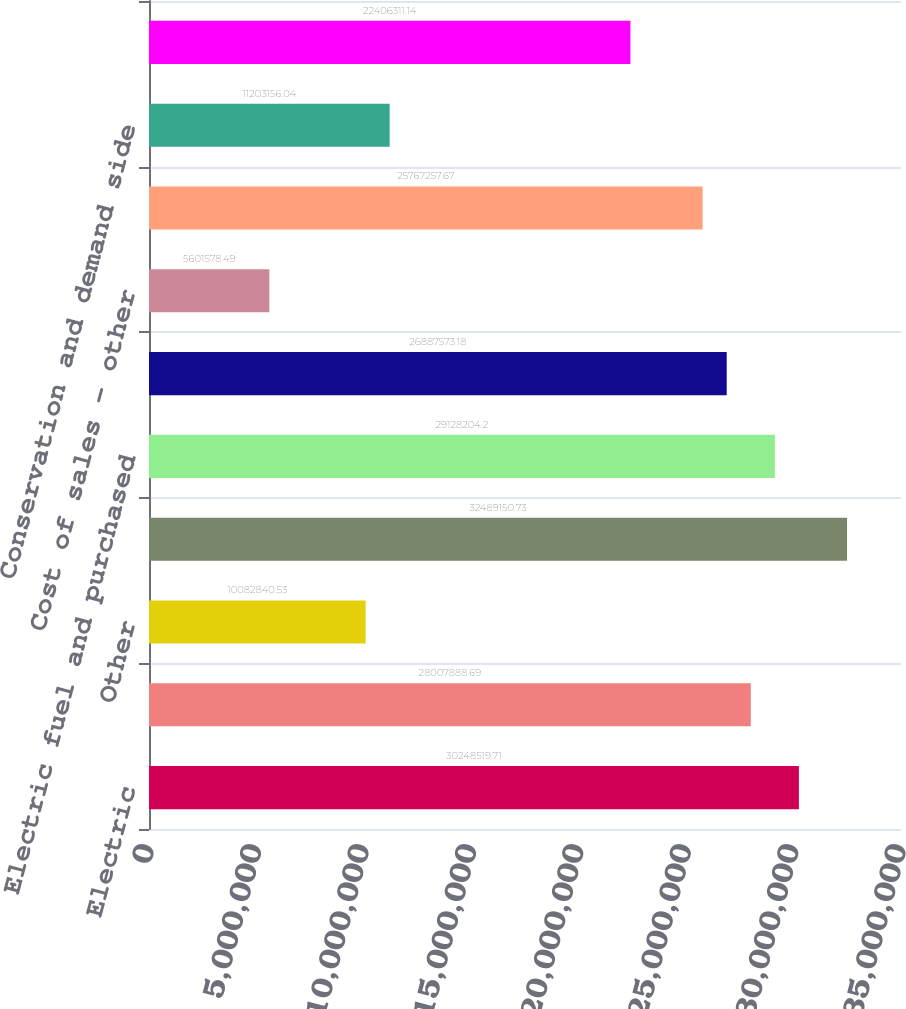Convert chart to OTSL. <chart><loc_0><loc_0><loc_500><loc_500><bar_chart><fcel>Electric<fcel>Natural gas<fcel>Other<fcel>Total operating revenues<fcel>Electric fuel and purchased<fcel>Cost of natural gas sold and<fcel>Cost of sales - other<fcel>Other operating and<fcel>Conservation and demand side<fcel>Depreciation and amortization<nl><fcel>3.02485e+07<fcel>2.80079e+07<fcel>1.00828e+07<fcel>3.24892e+07<fcel>2.91282e+07<fcel>2.68876e+07<fcel>5.60158e+06<fcel>2.57673e+07<fcel>1.12032e+07<fcel>2.24063e+07<nl></chart> 